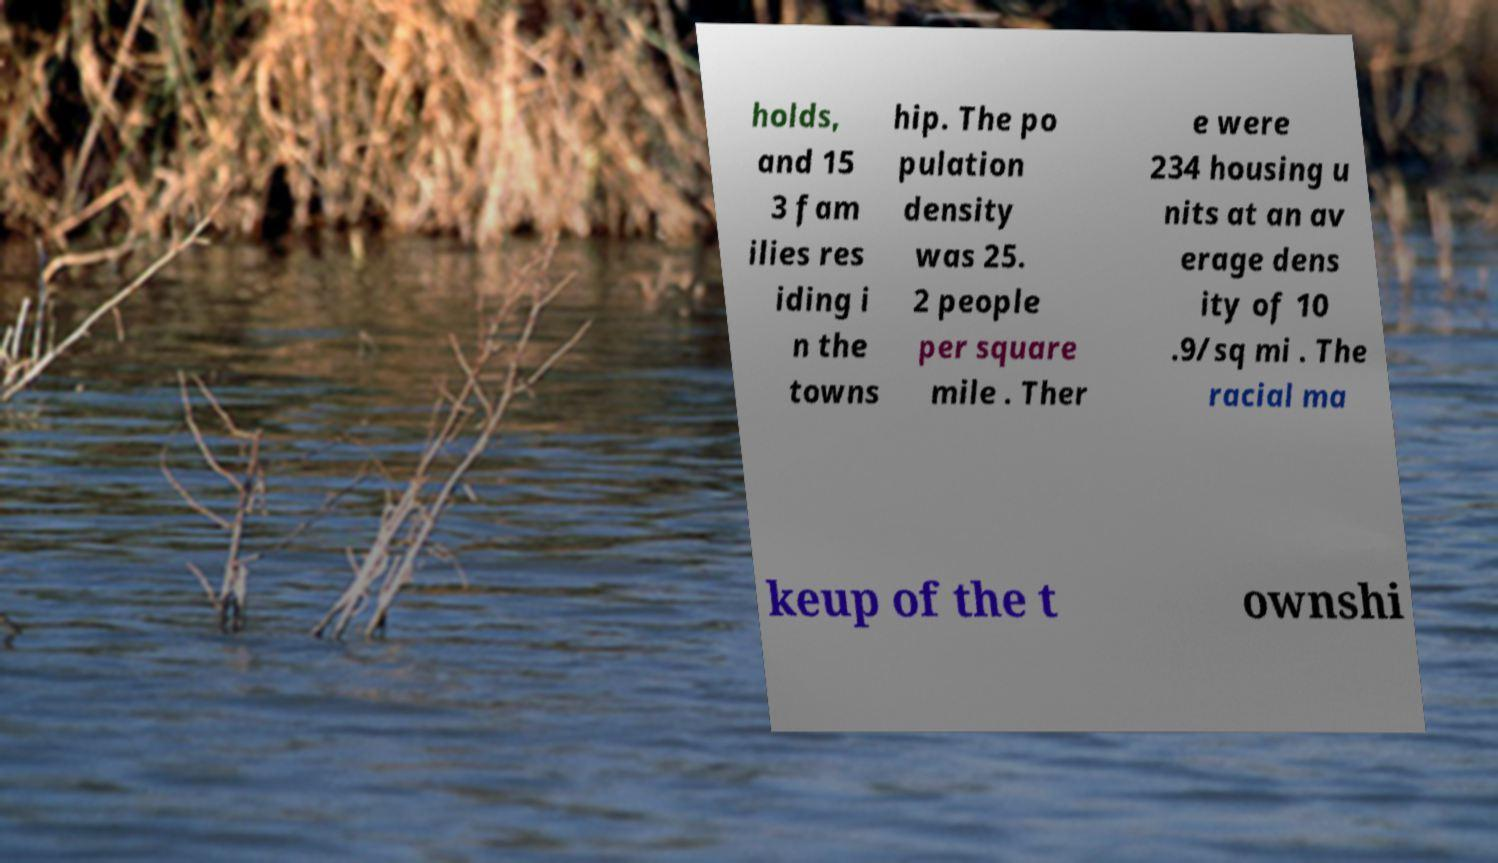What messages or text are displayed in this image? I need them in a readable, typed format. holds, and 15 3 fam ilies res iding i n the towns hip. The po pulation density was 25. 2 people per square mile . Ther e were 234 housing u nits at an av erage dens ity of 10 .9/sq mi . The racial ma keup of the t ownshi 